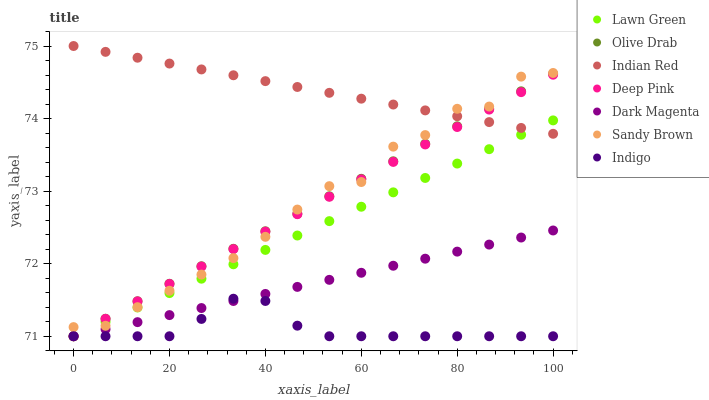Does Indigo have the minimum area under the curve?
Answer yes or no. Yes. Does Indian Red have the maximum area under the curve?
Answer yes or no. Yes. Does Deep Pink have the minimum area under the curve?
Answer yes or no. No. Does Deep Pink have the maximum area under the curve?
Answer yes or no. No. Is Lawn Green the smoothest?
Answer yes or no. Yes. Is Sandy Brown the roughest?
Answer yes or no. Yes. Is Deep Pink the smoothest?
Answer yes or no. No. Is Deep Pink the roughest?
Answer yes or no. No. Does Lawn Green have the lowest value?
Answer yes or no. Yes. Does Indian Red have the lowest value?
Answer yes or no. No. Does Indian Red have the highest value?
Answer yes or no. Yes. Does Deep Pink have the highest value?
Answer yes or no. No. Is Dark Magenta less than Sandy Brown?
Answer yes or no. Yes. Is Sandy Brown greater than Indigo?
Answer yes or no. Yes. Does Indian Red intersect Lawn Green?
Answer yes or no. Yes. Is Indian Red less than Lawn Green?
Answer yes or no. No. Is Indian Red greater than Lawn Green?
Answer yes or no. No. Does Dark Magenta intersect Sandy Brown?
Answer yes or no. No. 